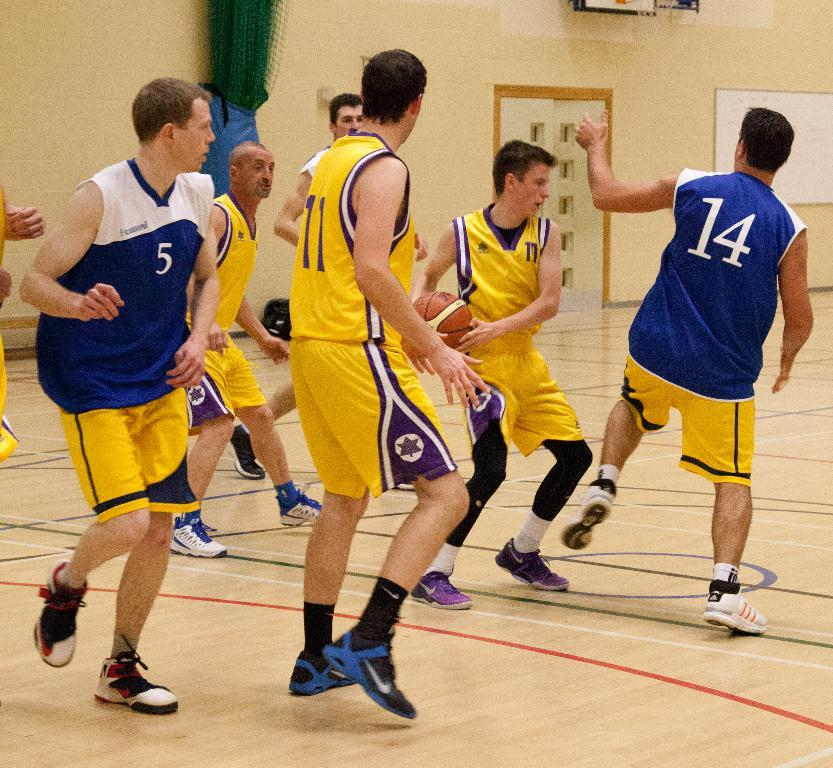<image>
Describe the image concisely. The basketball player in the number 17 jersey has the ball. 